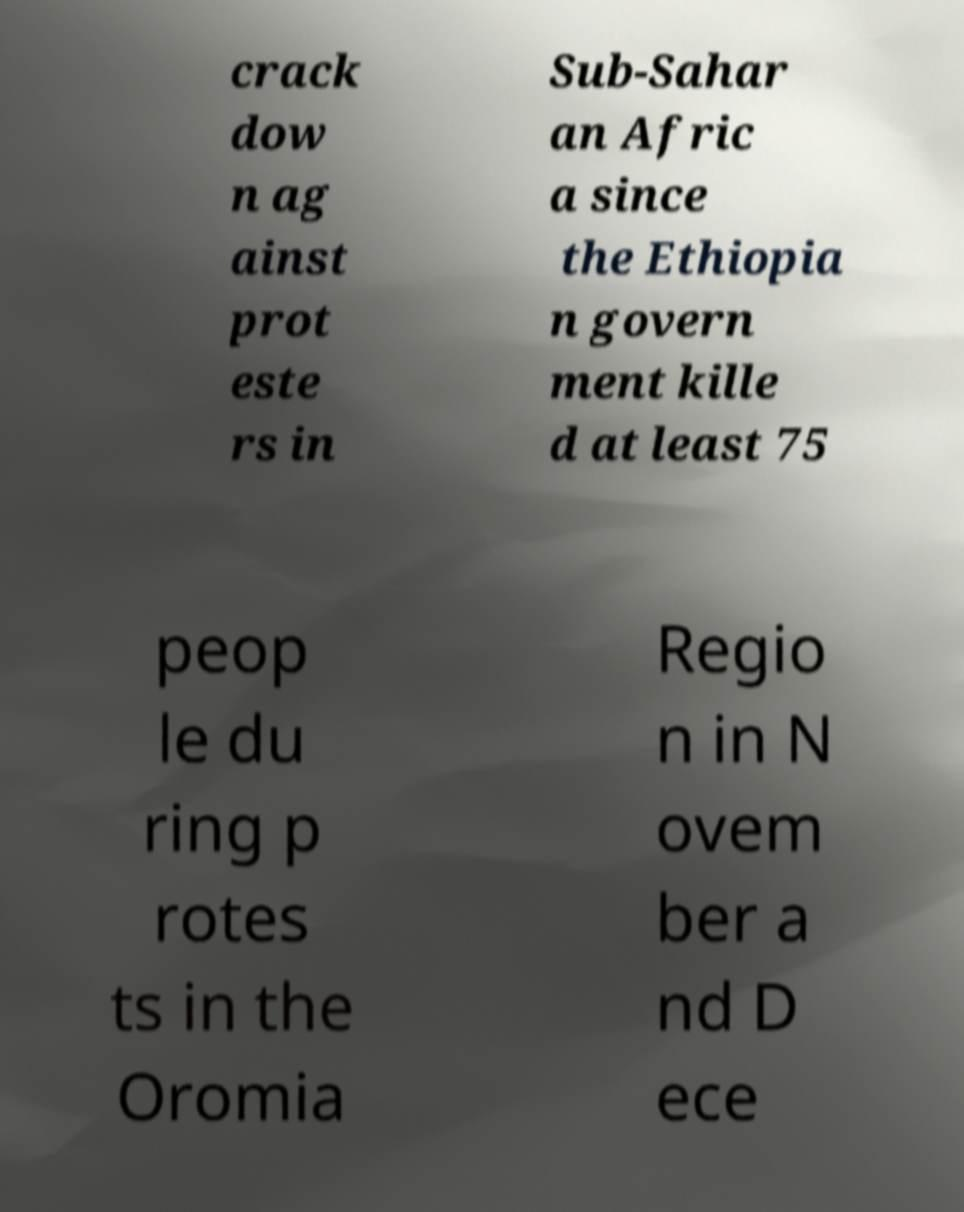Please identify and transcribe the text found in this image. crack dow n ag ainst prot este rs in Sub-Sahar an Afric a since the Ethiopia n govern ment kille d at least 75 peop le du ring p rotes ts in the Oromia Regio n in N ovem ber a nd D ece 